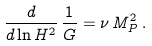<formula> <loc_0><loc_0><loc_500><loc_500>\frac { d } { d \ln H ^ { 2 } } \, \frac { 1 } { G } = \nu \, M _ { P } ^ { 2 } \, .</formula> 